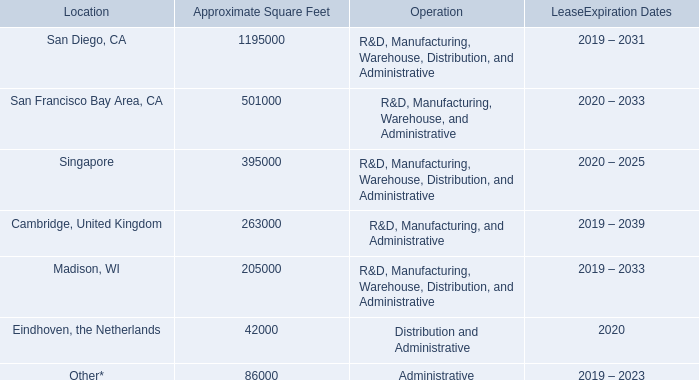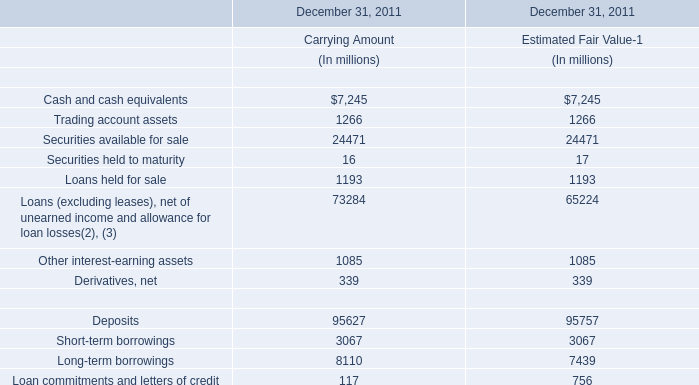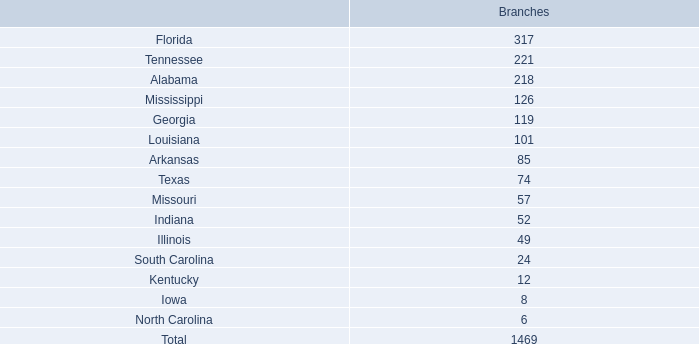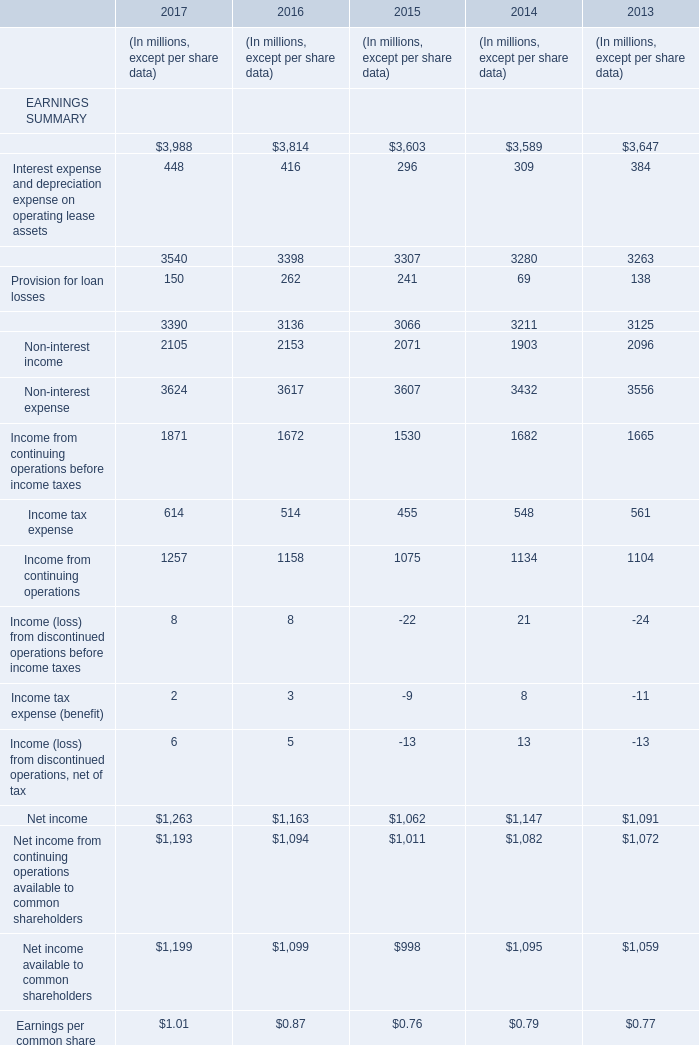What was the average value of the Net interest income and other financing income in the years where Interest income, including other financing income is positive? (in million) 
Computations: (((((3540 + 3398) + 3307) + 3280) + 3263) / 5)
Answer: 3357.6. 